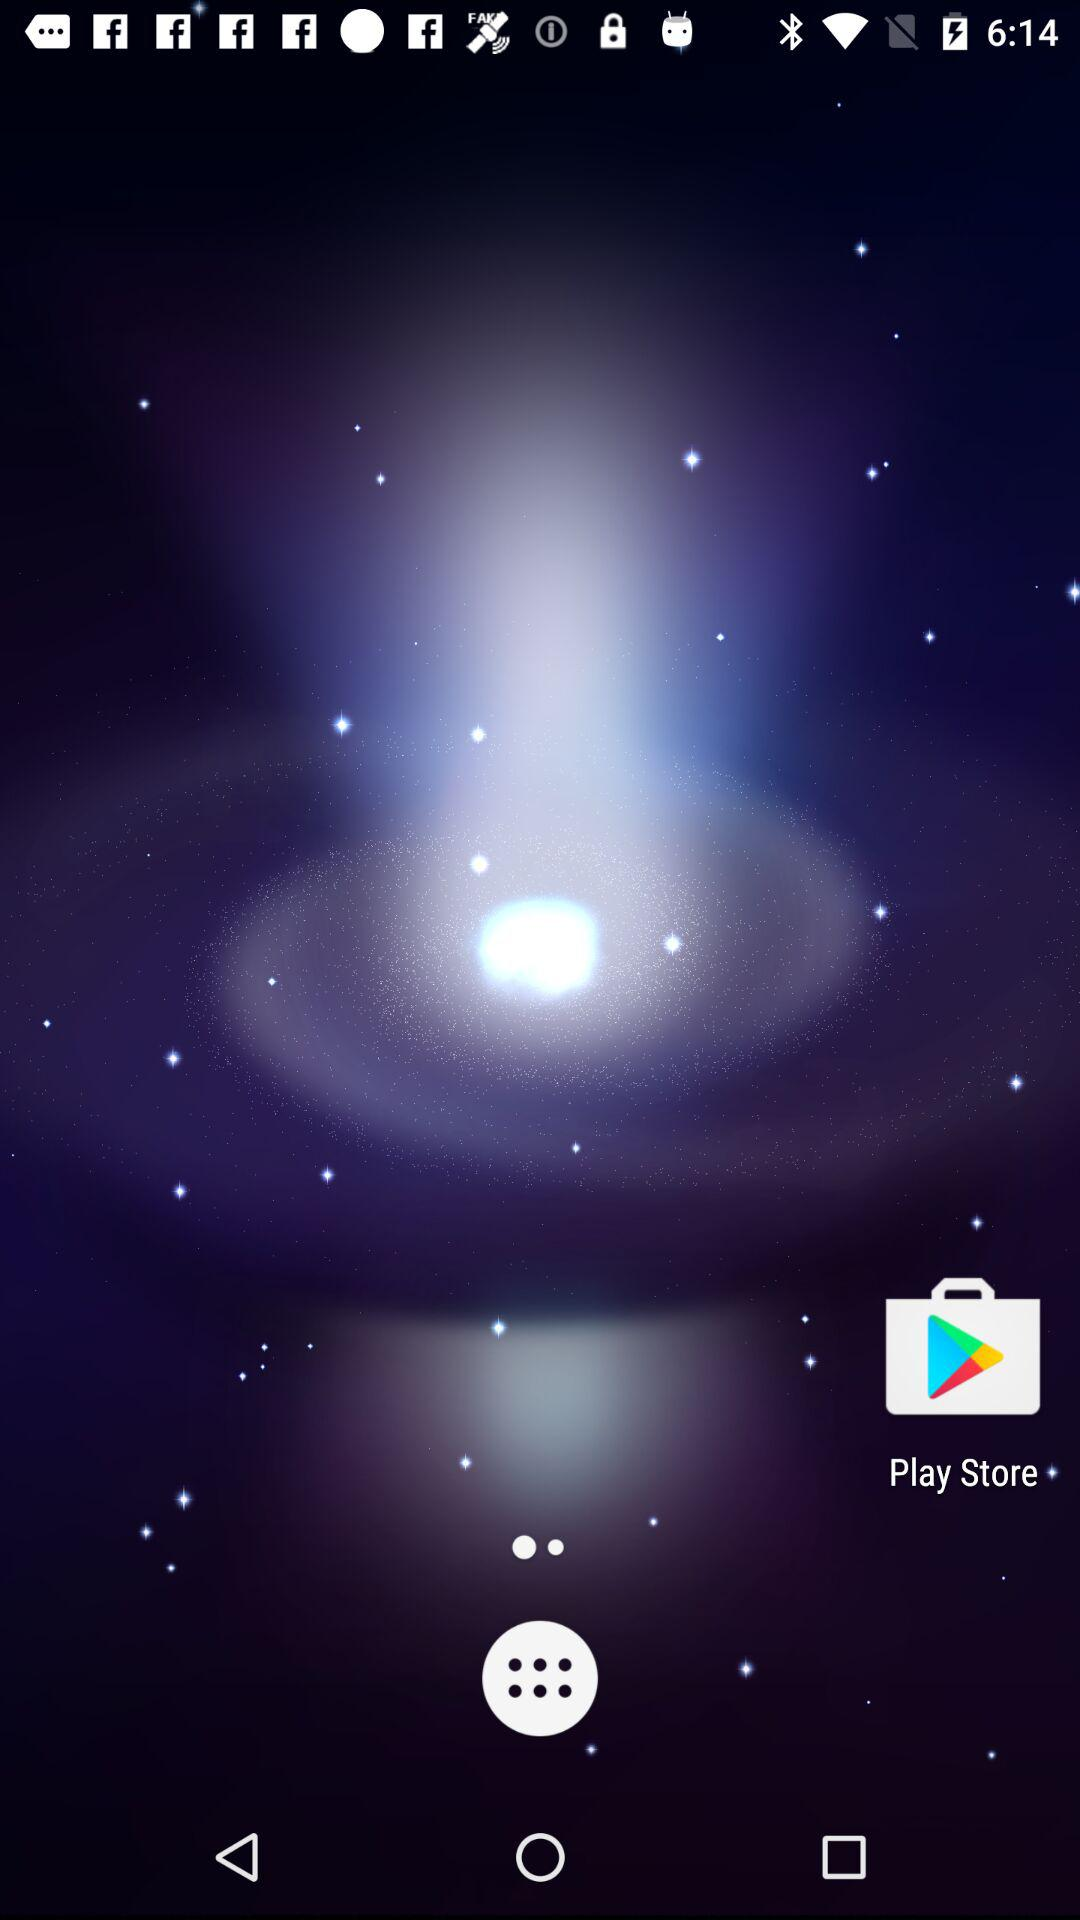What is the final price of Dannon Activia when using the coupon?
Answer the question using a single word or phrase. $1.19 